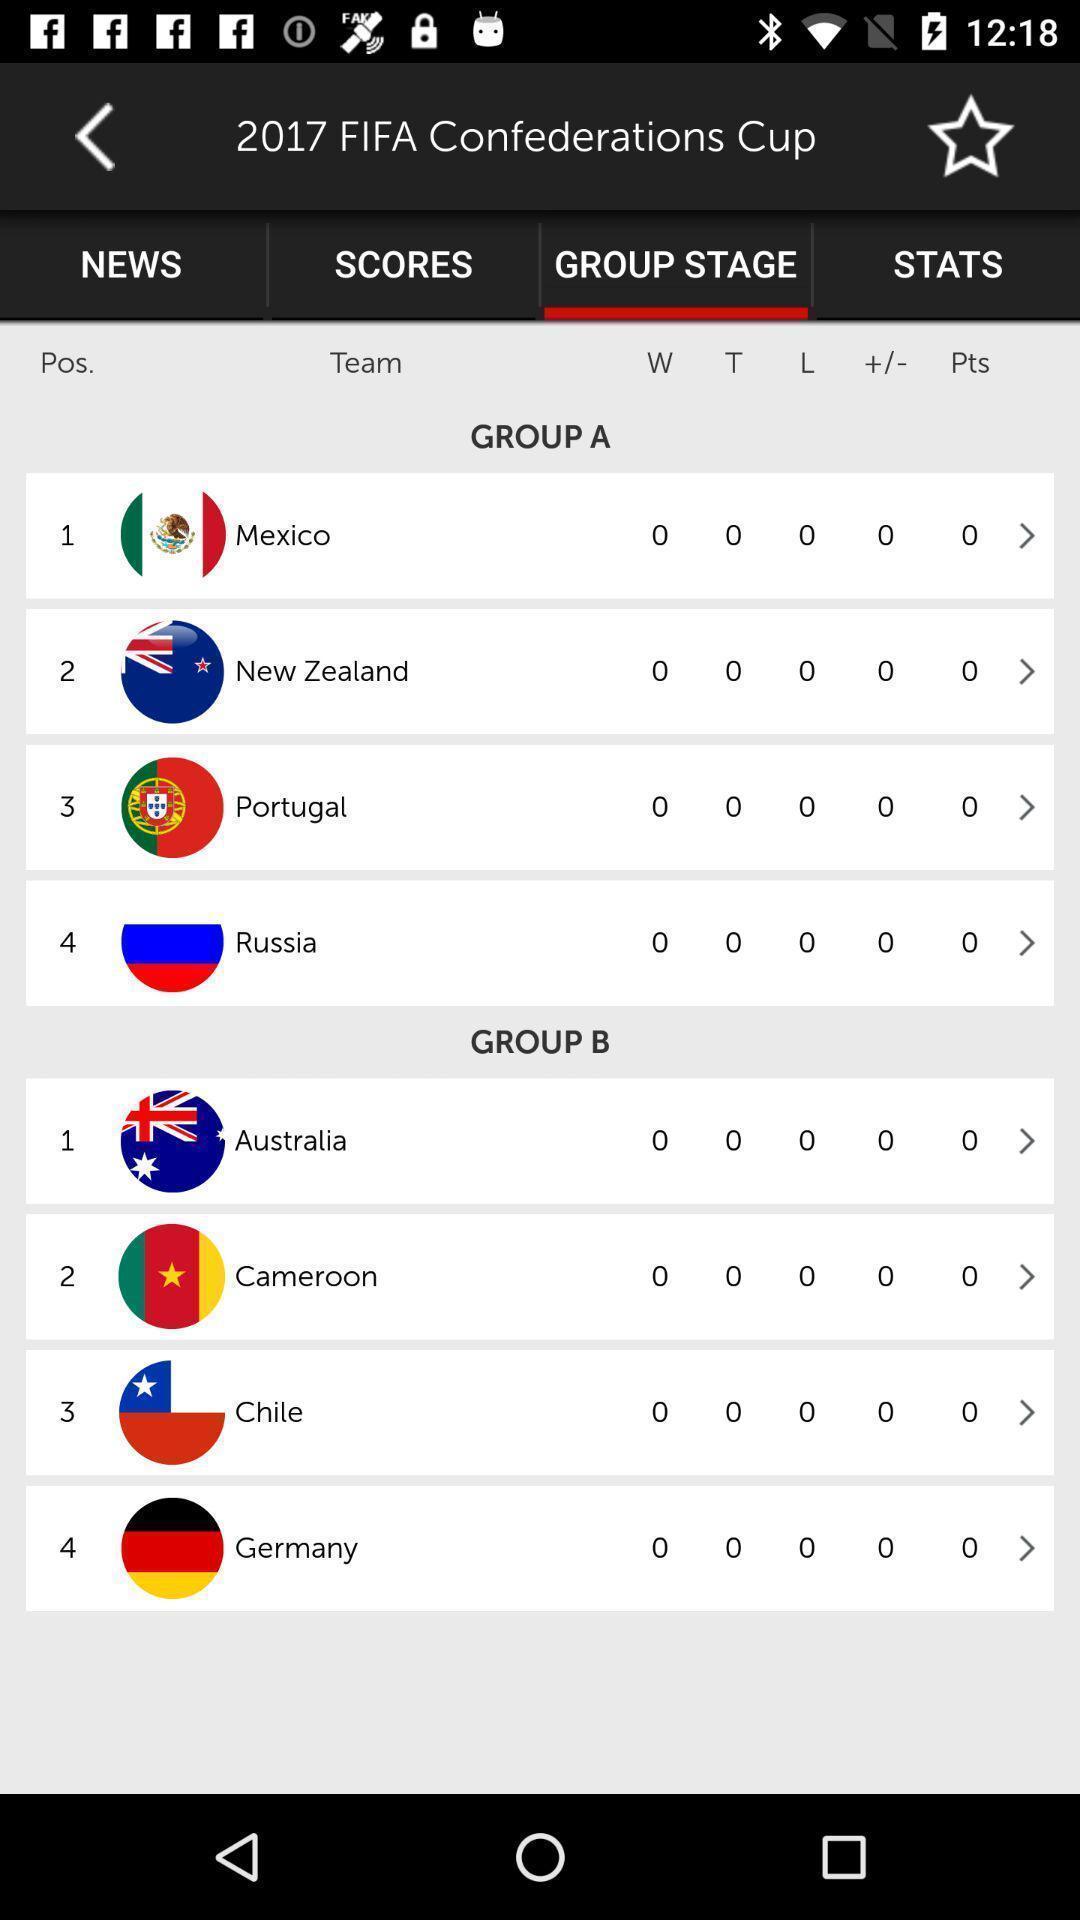Explain what's happening in this screen capture. Screen shows group stage details in a sports application. 